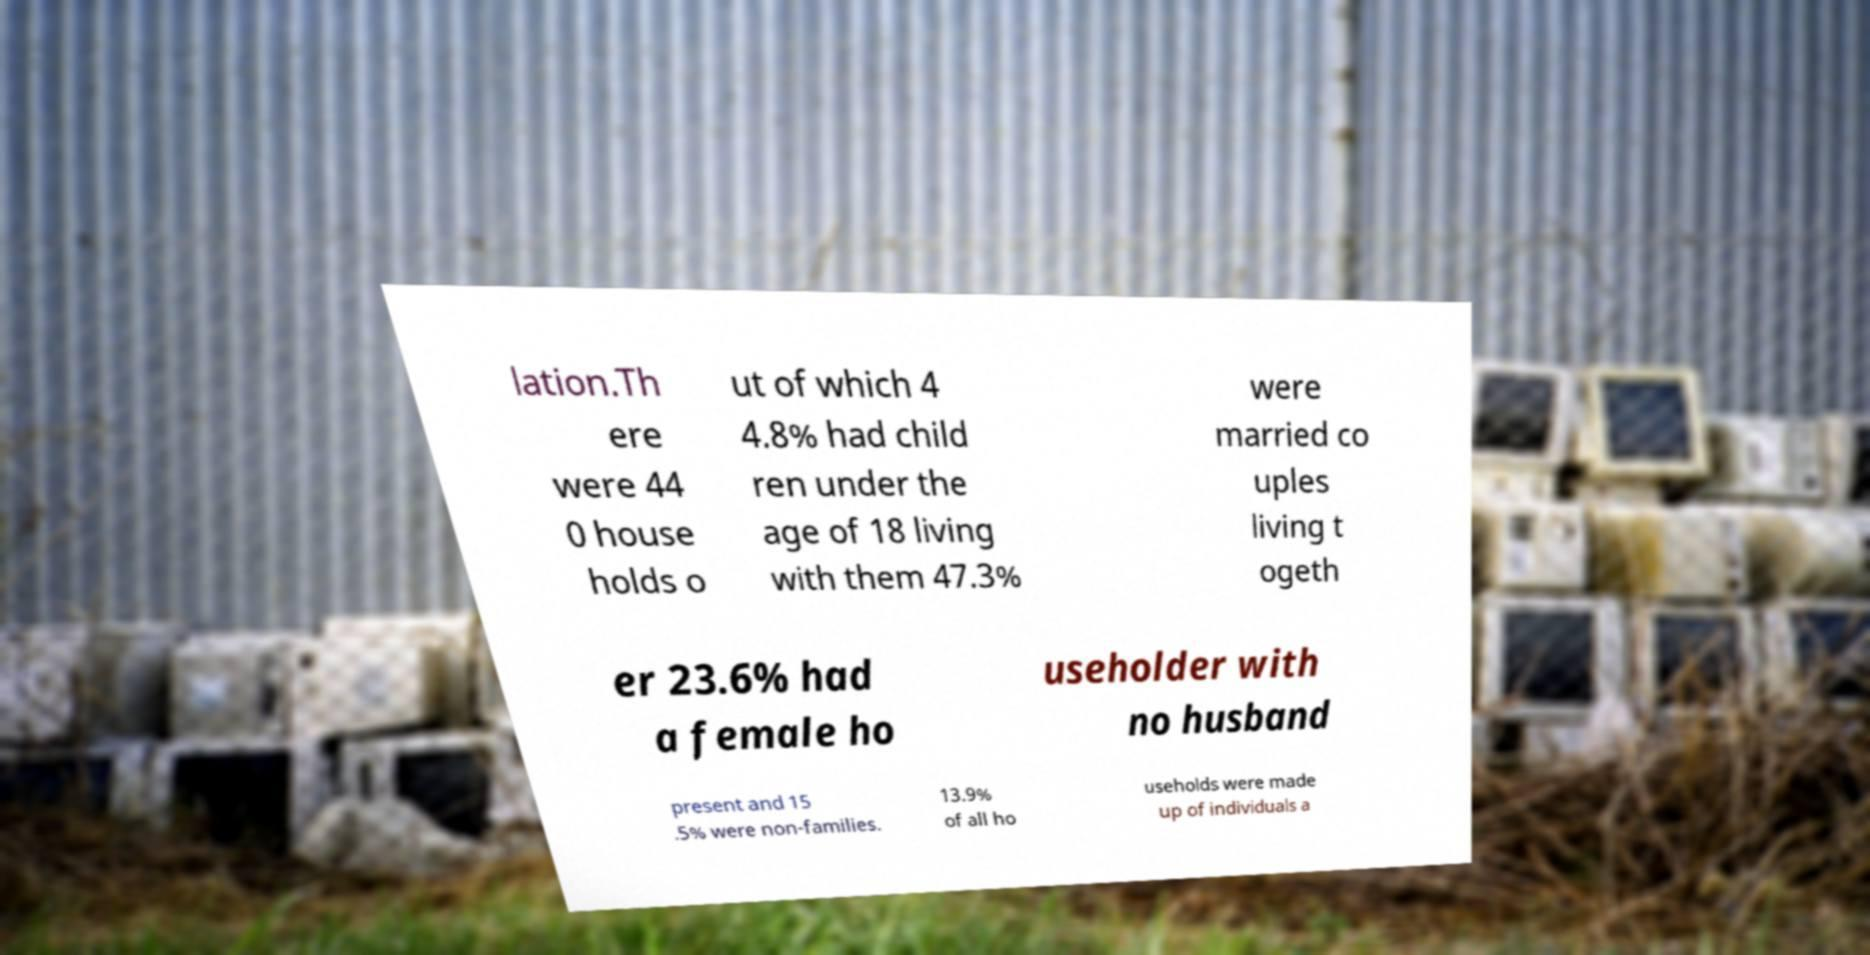There's text embedded in this image that I need extracted. Can you transcribe it verbatim? lation.Th ere were 44 0 house holds o ut of which 4 4.8% had child ren under the age of 18 living with them 47.3% were married co uples living t ogeth er 23.6% had a female ho useholder with no husband present and 15 .5% were non-families. 13.9% of all ho useholds were made up of individuals a 